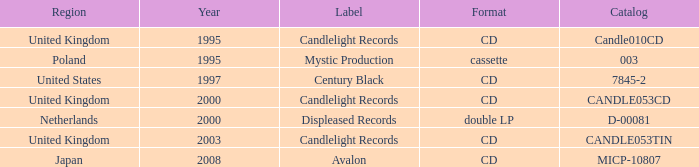What was the Candlelight Records Catalog of Candle053tin format? CD. Write the full table. {'header': ['Region', 'Year', 'Label', 'Format', 'Catalog'], 'rows': [['United Kingdom', '1995', 'Candlelight Records', 'CD', 'Candle010CD'], ['Poland', '1995', 'Mystic Production', 'cassette', '003'], ['United States', '1997', 'Century Black', 'CD', '7845-2'], ['United Kingdom', '2000', 'Candlelight Records', 'CD', 'CANDLE053CD'], ['Netherlands', '2000', 'Displeased Records', 'double LP', 'D-00081'], ['United Kingdom', '2003', 'Candlelight Records', 'CD', 'CANDLE053TIN'], ['Japan', '2008', 'Avalon', 'CD', 'MICP-10807']]} 